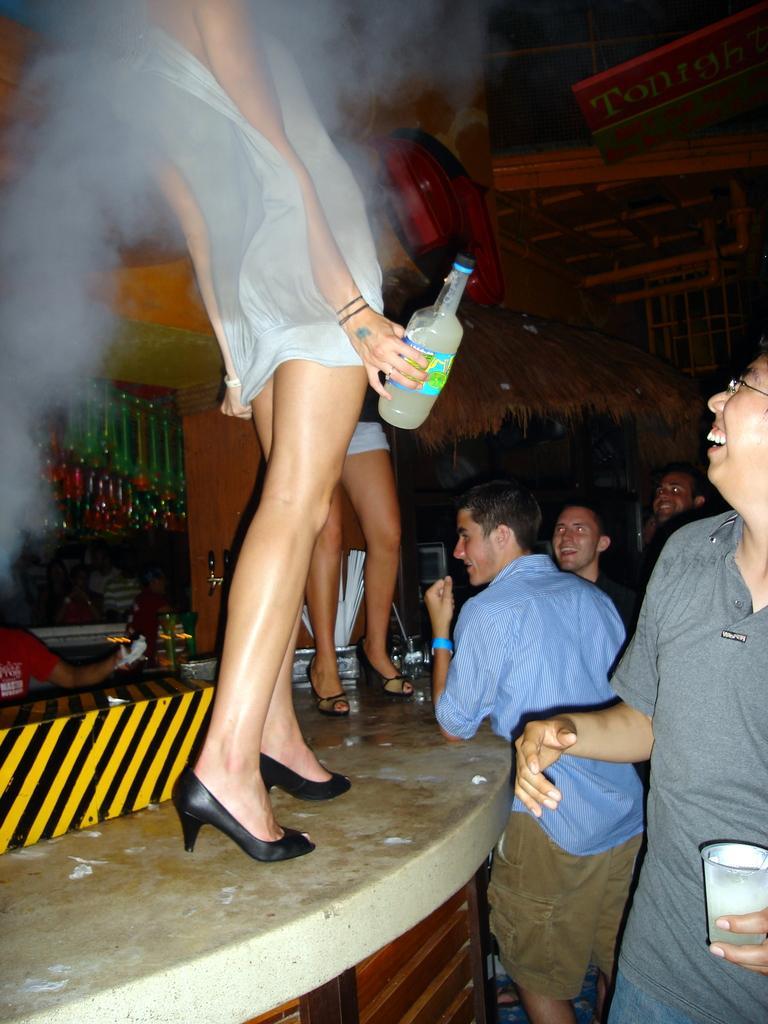Can you describe this image briefly? In this image, we can see two women standing on the stepped surface, on the right side, we can see some men standing. 